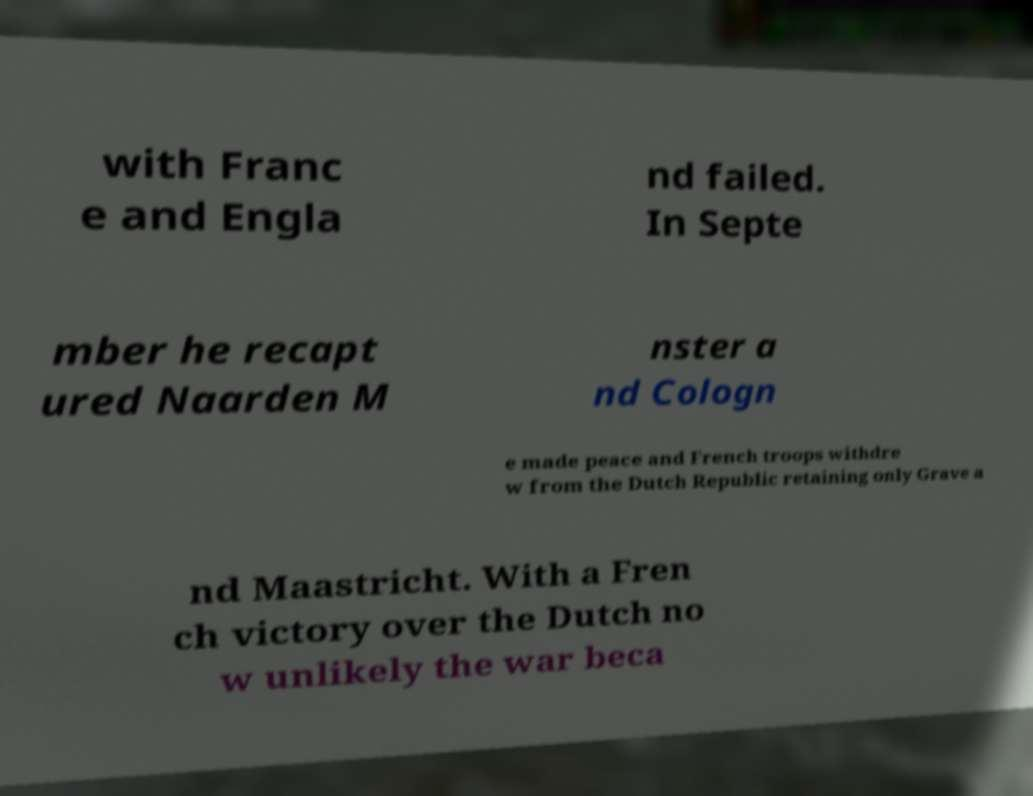Can you read and provide the text displayed in the image?This photo seems to have some interesting text. Can you extract and type it out for me? with Franc e and Engla nd failed. In Septe mber he recapt ured Naarden M nster a nd Cologn e made peace and French troops withdre w from the Dutch Republic retaining only Grave a nd Maastricht. With a Fren ch victory over the Dutch no w unlikely the war beca 